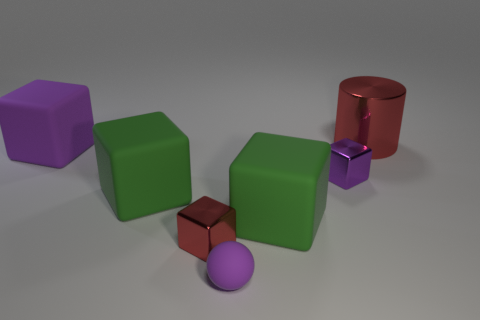Subtract 1 blocks. How many blocks are left? 4 Subtract all red cubes. How many cubes are left? 4 Subtract all blue blocks. Subtract all blue balls. How many blocks are left? 5 Add 1 big purple things. How many objects exist? 8 Subtract all balls. How many objects are left? 6 Add 6 small purple metal things. How many small purple metal things are left? 7 Add 7 small things. How many small things exist? 10 Subtract 0 gray blocks. How many objects are left? 7 Subtract all small blocks. Subtract all large red cylinders. How many objects are left? 4 